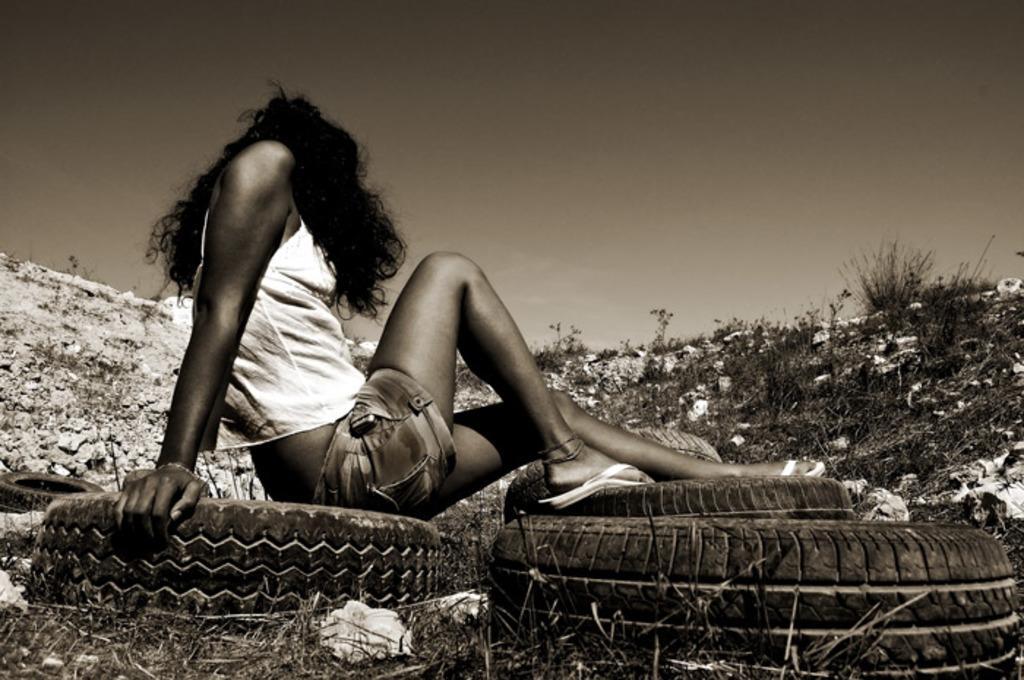How would you summarize this image in a sentence or two? In this image we can see black and white picture of a woman sitting on the Tyre. In the foreground we can see group of tyres and in the background we can see group of plants and sky. 